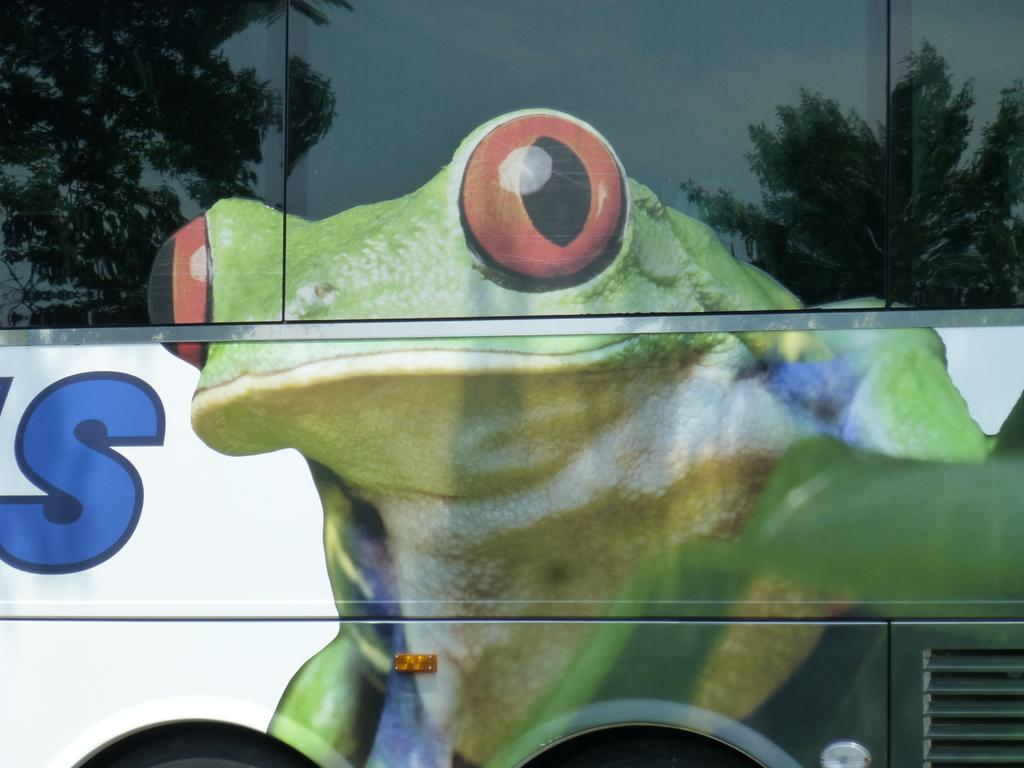What is the main subject of the image? The image is a zoomed in picture of a vehicle. What can be seen inside the vehicle? There is a picture of a frog in the vehicle. What type of natural scenery is visible in the image? Trees are visible in the image. How can the sky be seen in the image? The sky is visible through a reflection in the image. What type of chess piece is visible in the image? There is no chess piece present in the image. Can you tell me which tooth is missing in the image? There is no tooth visible in the image. 